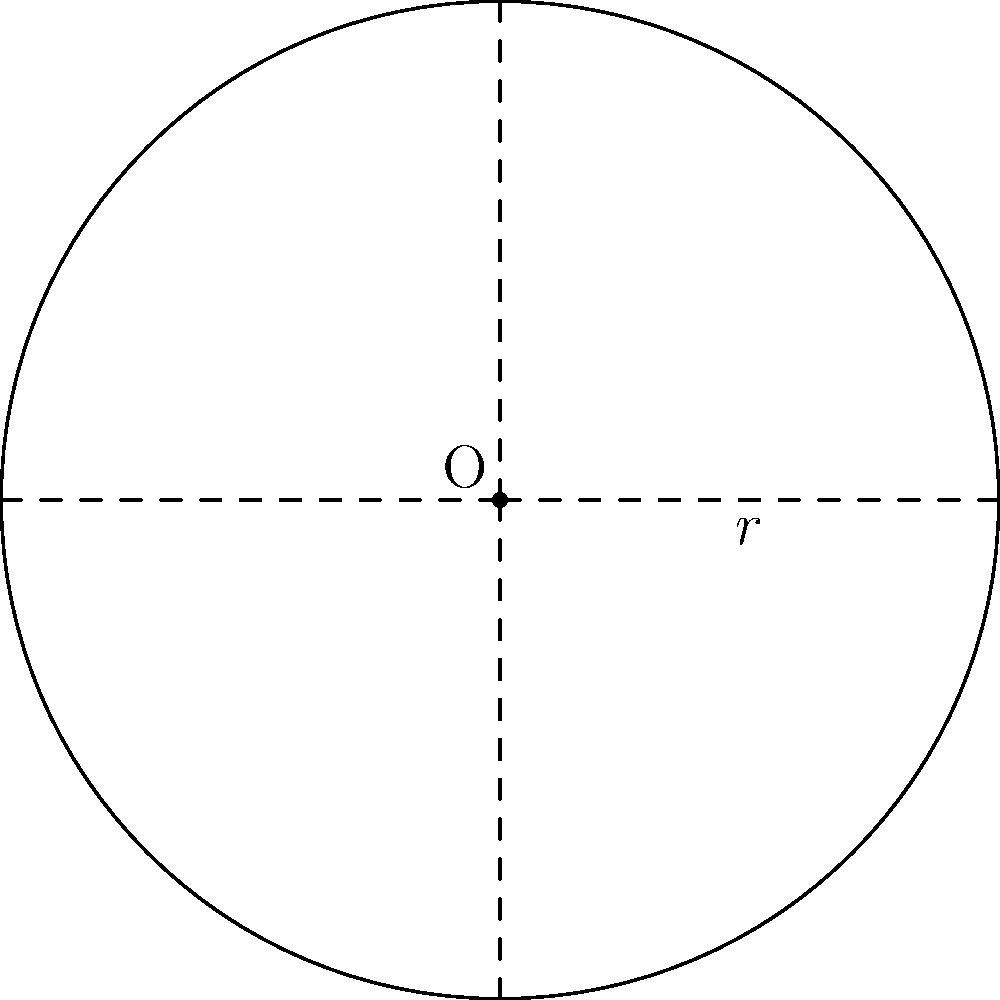As a retired firefighter, you're tasked with determining the area of a circular fire safety zone. If the radius of the safety zone is 30 meters, what is the total area that needs to be cleared? Round your answer to the nearest whole number. To find the area of a circular fire safety zone, we need to use the formula for the area of a circle:

$$A = \pi r^2$$

Where:
$A$ = area of the circle
$\pi$ = pi (approximately 3.14159)
$r$ = radius of the circle

Given:
$r = 30$ meters

Step 1: Substitute the given radius into the formula.
$$A = \pi (30)^2$$

Step 2: Calculate the square of the radius.
$$A = \pi (900)$$

Step 3: Multiply by $\pi$.
$$A = 2,827.43... \text{ square meters}$$

Step 4: Round to the nearest whole number.
$$A \approx 2,827 \text{ square meters}$$

Therefore, the total area that needs to be cleared for the fire safety zone is approximately 2,827 square meters.
Answer: 2,827 square meters 